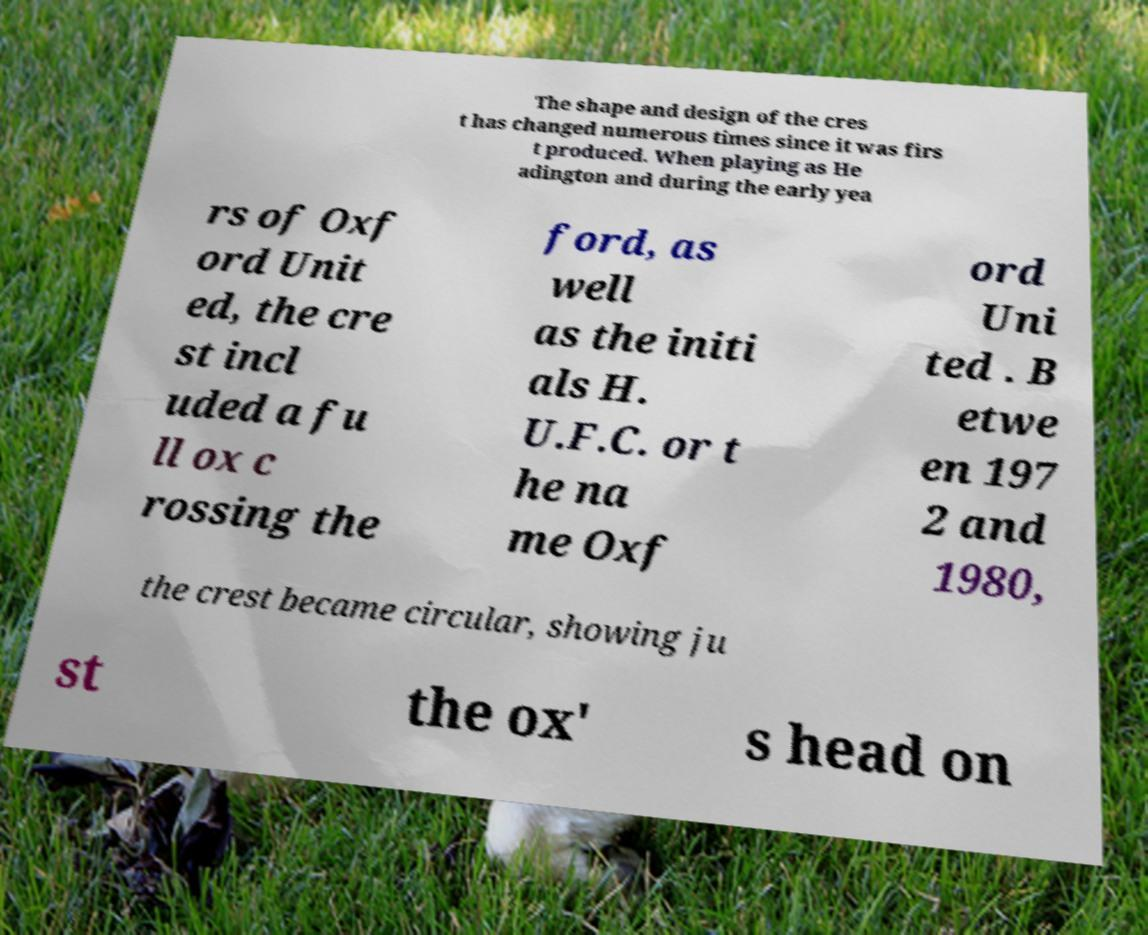Can you accurately transcribe the text from the provided image for me? The shape and design of the cres t has changed numerous times since it was firs t produced. When playing as He adington and during the early yea rs of Oxf ord Unit ed, the cre st incl uded a fu ll ox c rossing the ford, as well as the initi als H. U.F.C. or t he na me Oxf ord Uni ted . B etwe en 197 2 and 1980, the crest became circular, showing ju st the ox' s head on 